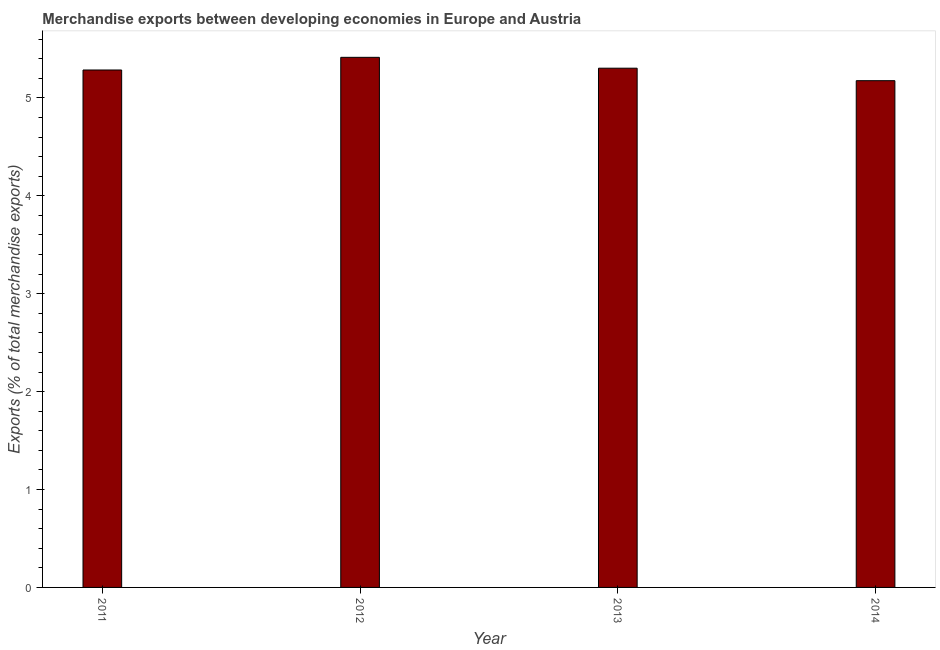Does the graph contain any zero values?
Make the answer very short. No. What is the title of the graph?
Make the answer very short. Merchandise exports between developing economies in Europe and Austria. What is the label or title of the X-axis?
Ensure brevity in your answer.  Year. What is the label or title of the Y-axis?
Your response must be concise. Exports (% of total merchandise exports). What is the merchandise exports in 2011?
Offer a terse response. 5.28. Across all years, what is the maximum merchandise exports?
Provide a short and direct response. 5.41. Across all years, what is the minimum merchandise exports?
Provide a succinct answer. 5.18. In which year was the merchandise exports minimum?
Keep it short and to the point. 2014. What is the sum of the merchandise exports?
Offer a very short reply. 21.18. What is the difference between the merchandise exports in 2011 and 2014?
Ensure brevity in your answer.  0.11. What is the average merchandise exports per year?
Provide a short and direct response. 5.29. What is the median merchandise exports?
Your response must be concise. 5.29. Do a majority of the years between 2014 and 2011 (inclusive) have merchandise exports greater than 1.2 %?
Give a very brief answer. Yes. Is the merchandise exports in 2012 less than that in 2013?
Ensure brevity in your answer.  No. What is the difference between the highest and the second highest merchandise exports?
Provide a short and direct response. 0.11. What is the difference between the highest and the lowest merchandise exports?
Your answer should be very brief. 0.24. In how many years, is the merchandise exports greater than the average merchandise exports taken over all years?
Ensure brevity in your answer.  2. How many bars are there?
Your response must be concise. 4. How many years are there in the graph?
Keep it short and to the point. 4. What is the difference between two consecutive major ticks on the Y-axis?
Provide a short and direct response. 1. Are the values on the major ticks of Y-axis written in scientific E-notation?
Provide a succinct answer. No. What is the Exports (% of total merchandise exports) in 2011?
Offer a terse response. 5.28. What is the Exports (% of total merchandise exports) of 2012?
Give a very brief answer. 5.41. What is the Exports (% of total merchandise exports) in 2013?
Ensure brevity in your answer.  5.3. What is the Exports (% of total merchandise exports) of 2014?
Give a very brief answer. 5.18. What is the difference between the Exports (% of total merchandise exports) in 2011 and 2012?
Your answer should be compact. -0.13. What is the difference between the Exports (% of total merchandise exports) in 2011 and 2013?
Keep it short and to the point. -0.02. What is the difference between the Exports (% of total merchandise exports) in 2011 and 2014?
Your response must be concise. 0.11. What is the difference between the Exports (% of total merchandise exports) in 2012 and 2013?
Offer a very short reply. 0.11. What is the difference between the Exports (% of total merchandise exports) in 2012 and 2014?
Ensure brevity in your answer.  0.24. What is the difference between the Exports (% of total merchandise exports) in 2013 and 2014?
Provide a succinct answer. 0.13. What is the ratio of the Exports (% of total merchandise exports) in 2011 to that in 2012?
Provide a succinct answer. 0.98. What is the ratio of the Exports (% of total merchandise exports) in 2011 to that in 2013?
Your answer should be compact. 1. What is the ratio of the Exports (% of total merchandise exports) in 2011 to that in 2014?
Keep it short and to the point. 1.02. What is the ratio of the Exports (% of total merchandise exports) in 2012 to that in 2014?
Give a very brief answer. 1.05. What is the ratio of the Exports (% of total merchandise exports) in 2013 to that in 2014?
Make the answer very short. 1.02. 